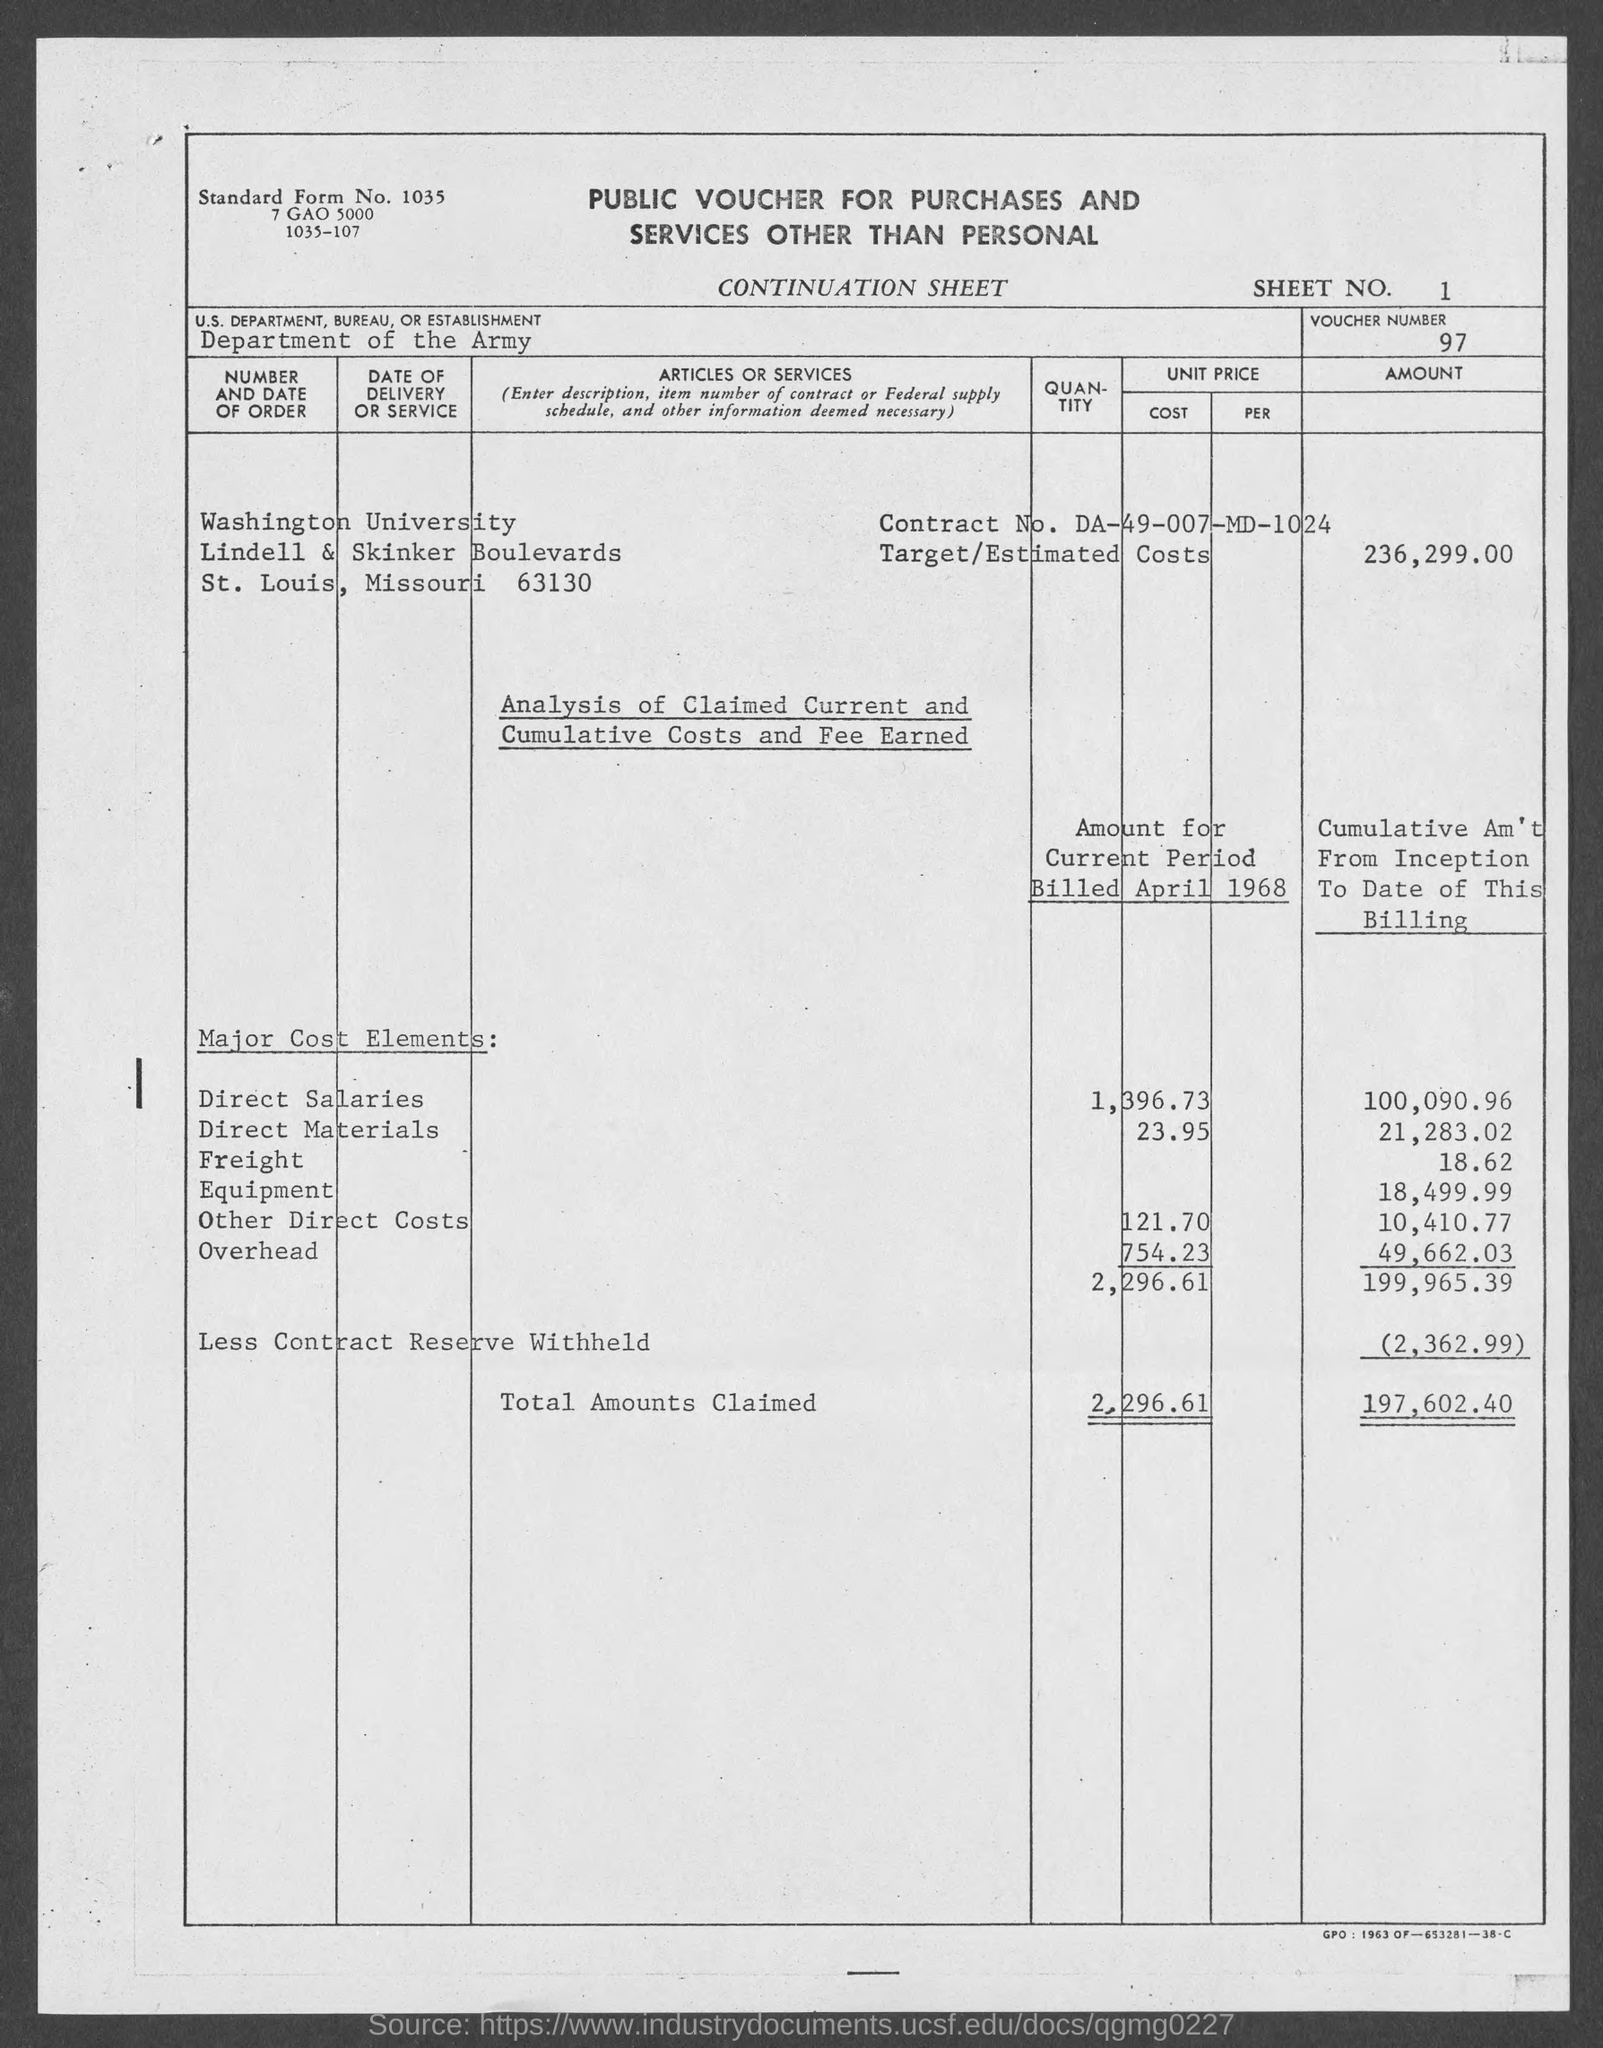Outline some significant characteristics in this image. Washington University is located in St. Louis County. Here is a sheet number 1 to 12. Washington University has a street address located at Lindell & Skinker Boulevards. The Department of the Army is referred to as the US Department in vouchers. The voucher number is 97... 